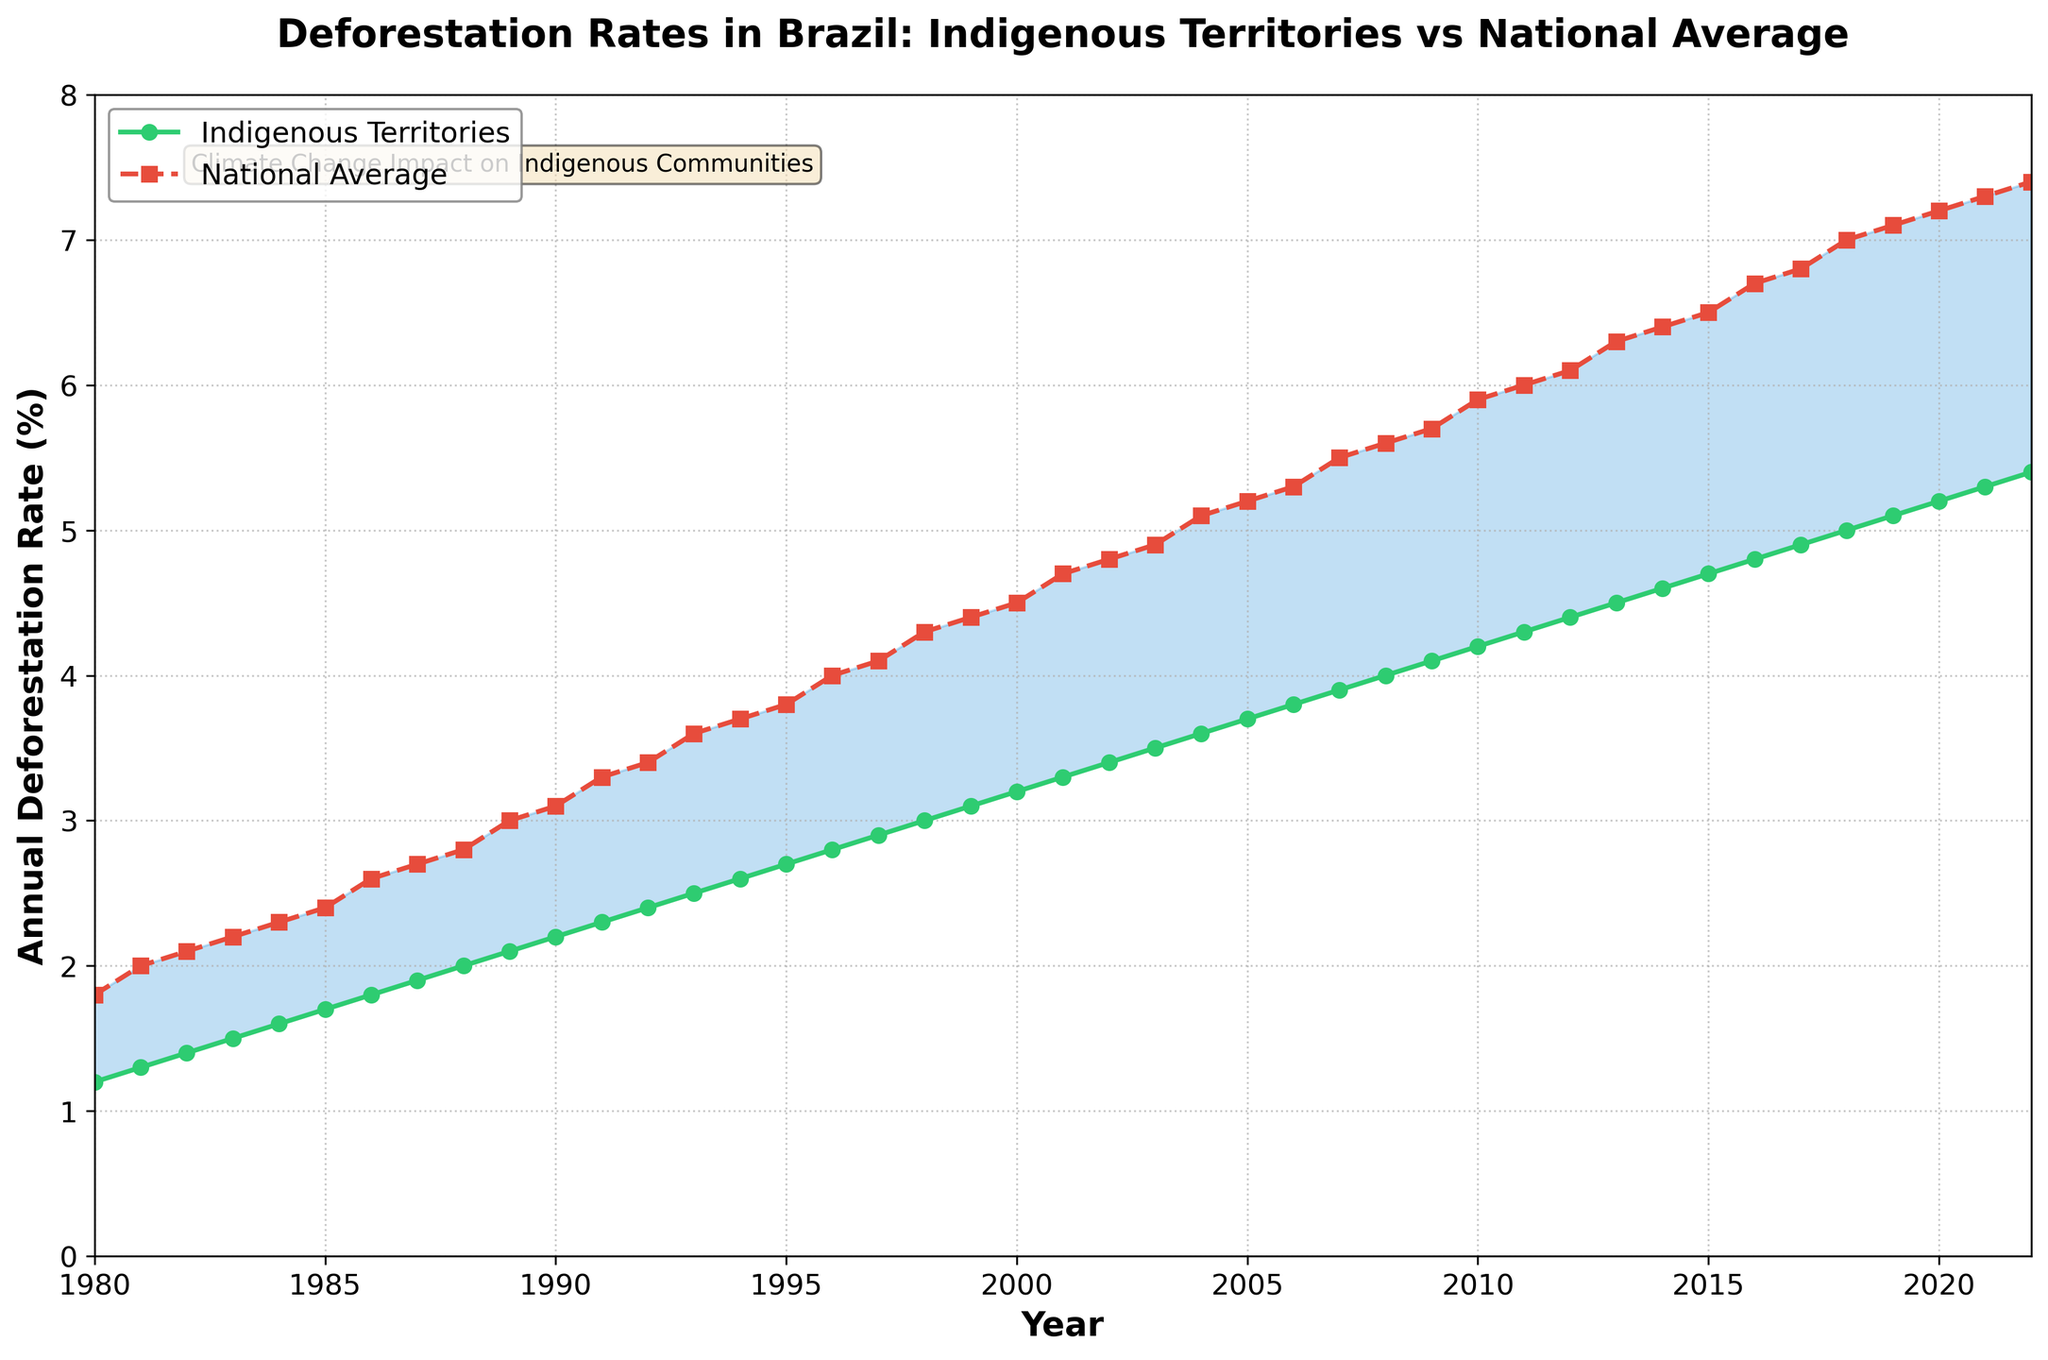What is the title of the figure? The title is located at the top center of the figure. It reads "Deforestation Rates in Brazil: Indigenous Territories vs National Average".
Answer: Deforestation Rates in Brazil: Indigenous Territories vs National Average What are the two categories shown in the figure? The two categories are represented by different lines and markers. The legend indicates these categories as "Indigenous Territories" and "National Average".
Answer: Indigenous Territories and National Average What color represents the deforestation rate in indigenous territories? The color of the line graphs can be identified visually. The line representing "Indigenous Territories" is green.
Answer: Green In what year did the deforestation rate in indigenous territories reach 4.0%? To answer this, find the year where the "Indigenous Territories" line crosses the 4.0% deforestation rate on the y-axis. This occurs at the year marker for 2008.
Answer: 2008 By how much did the national average deforestation rate exceed the indigenous territories' rate in 2020? Check the values at 2020 for both series. The national rate is 7.2%, and the indigenous rate is 5.2%. Subtract 5.2 from 7.2 to find the difference.
Answer: 2.0% Which year shows the smallest difference between the national average and indigenous territories' deforestation rates? Visually inspect the areas where the shaded gap is the narrowest. The smallest gap appears in the early years, so comparing values, 1980 shows a minimal difference (1.8% - 1.2% = 0.6%).
Answer: 1980 How much did the deforestation rate in indigenous territories increase from 1990 to 2022? Look up the values for these years: 1990 (2.2%) and 2022 (5.4%). Calculate the difference: 5.4% - 2.2%.
Answer: 3.2% Which year had the highest national average deforestation rate? Check the y-axis peak for the "National Average" line. The highest point is in 2022 with 7.4%.
Answer: 2022 Compare the trends of the two deforestation rates from 1980 to 2022. Observe the shapes and slopes of both lines. Both show an increasing trend, but the national average consistently remains higher and the gap between the two rates appears to widen over time.
Answer: Both increase; national average consistently higher, gap widens over time 